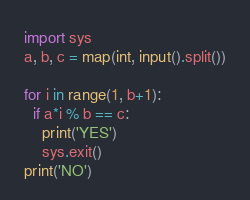Convert code to text. <code><loc_0><loc_0><loc_500><loc_500><_Python_>import sys
a, b, c = map(int, input().split())

for i in range(1, b+1):
  if a*i % b == c:
    print('YES')
    sys.exit()
print('NO')
</code> 